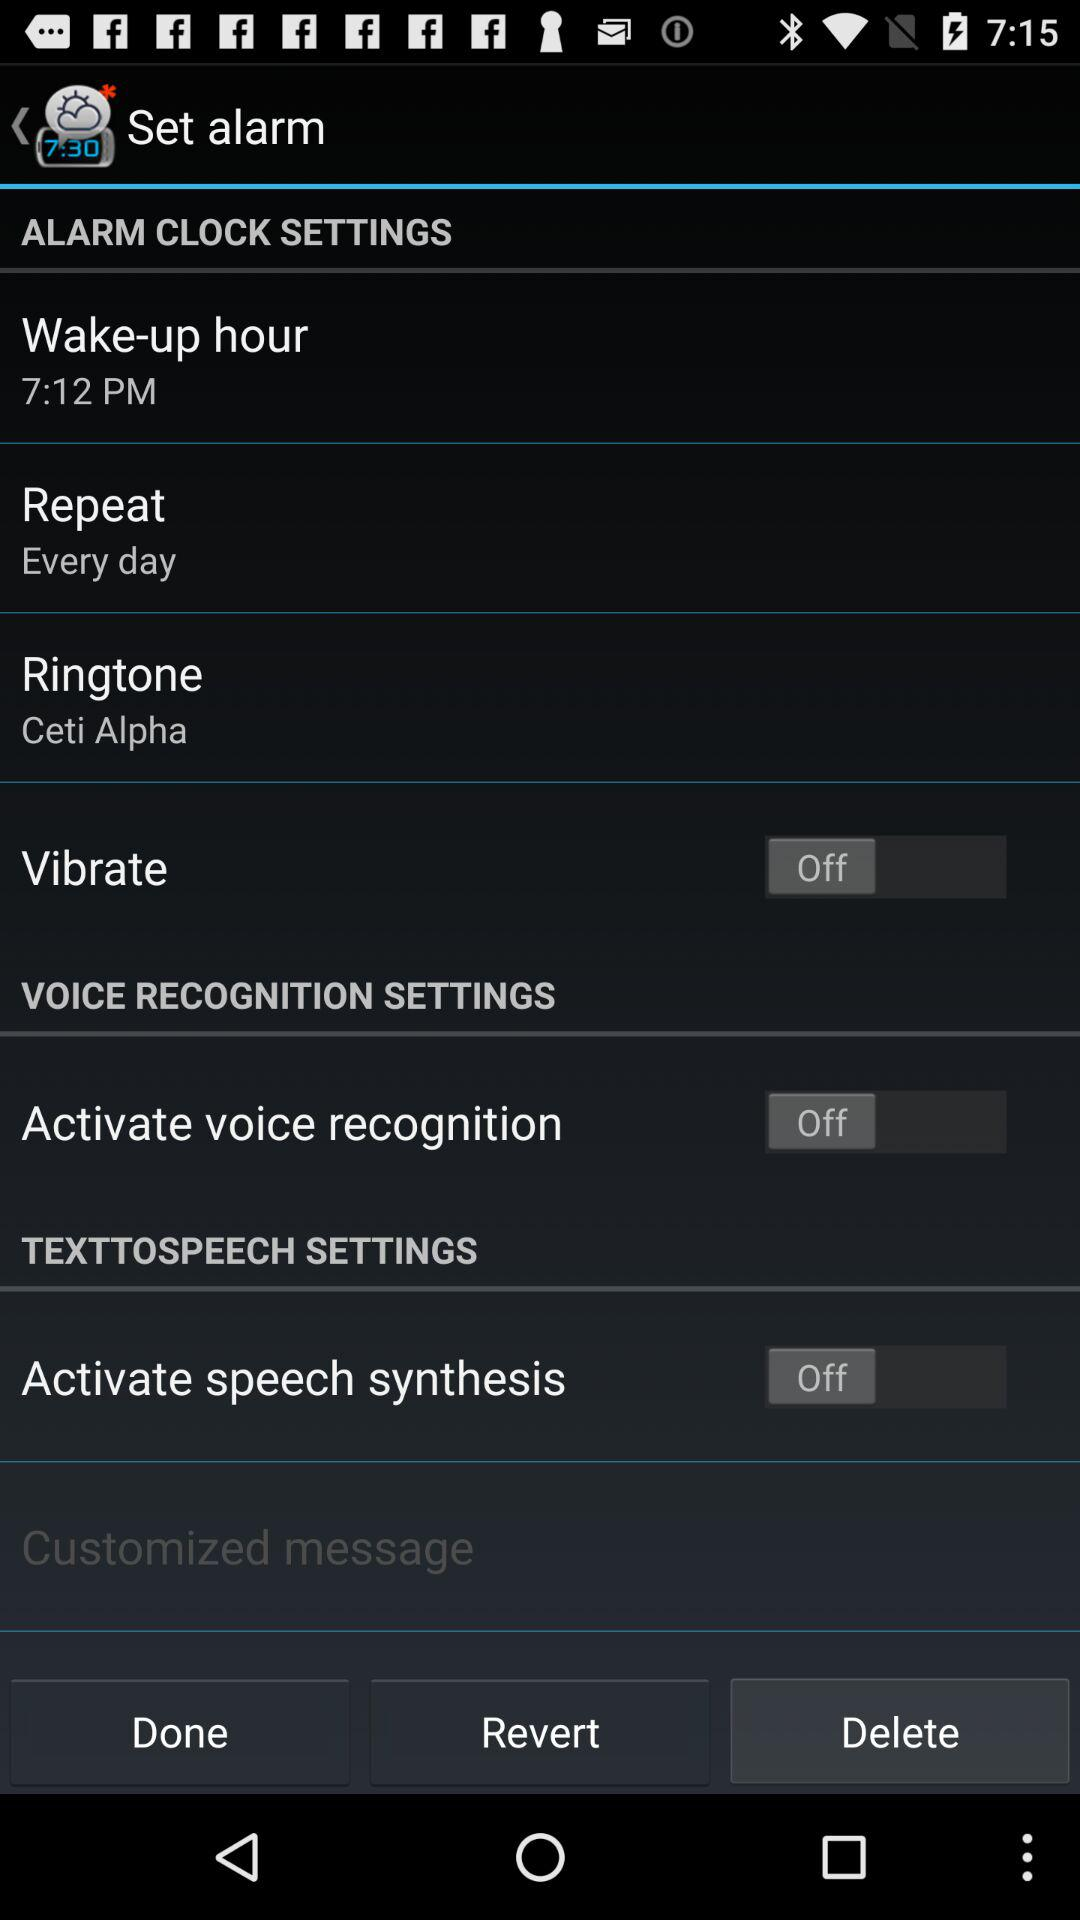What is the status of "Activate voice recognition"? The status of "Activate voice recognition" is "off". 